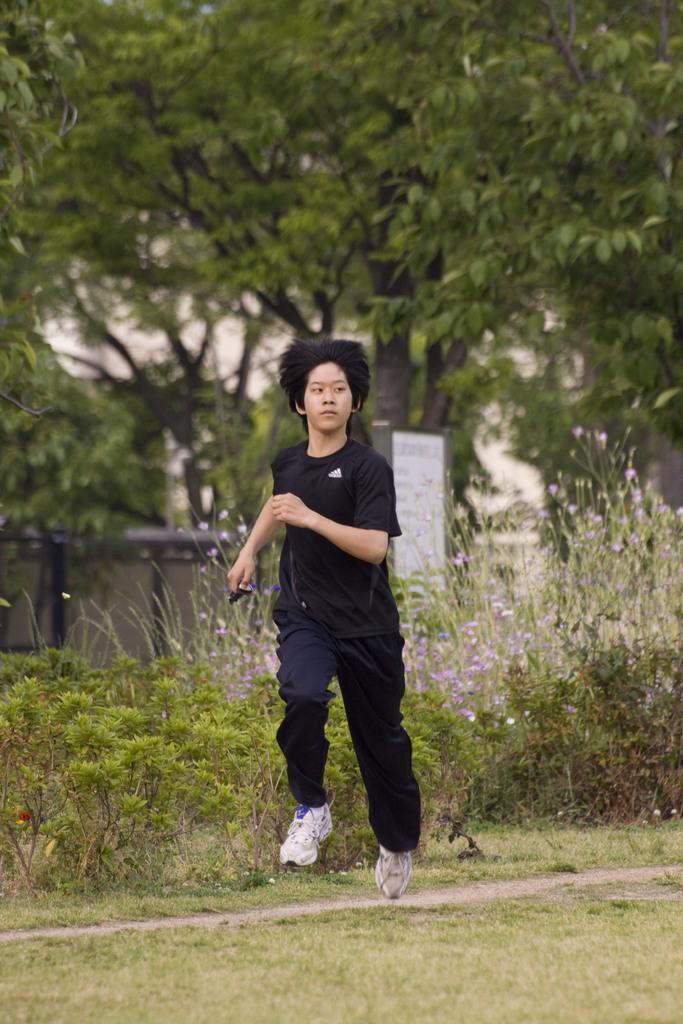Please provide a concise description of this image. This picture is called outside. In the center there is a person wearing black color t-shirt and running on the ground. We can see the green grass, plants, flowers, sky, building and a fence. 